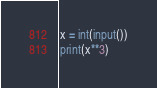<code> <loc_0><loc_0><loc_500><loc_500><_Python_>x = int(input())
print(x**3)

</code> 